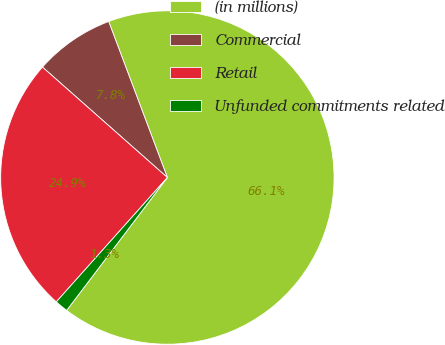<chart> <loc_0><loc_0><loc_500><loc_500><pie_chart><fcel>(in millions)<fcel>Commercial<fcel>Retail<fcel>Unfunded commitments related<nl><fcel>66.05%<fcel>7.75%<fcel>24.92%<fcel>1.28%<nl></chart> 